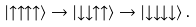Convert formula to latex. <formula><loc_0><loc_0><loc_500><loc_500>\left | \uparrow \uparrow \uparrow \uparrow \right > \rightarrow \left | \downarrow \downarrow \uparrow \uparrow \right > \rightarrow \left | \downarrow \downarrow \downarrow \downarrow \right > .</formula> 